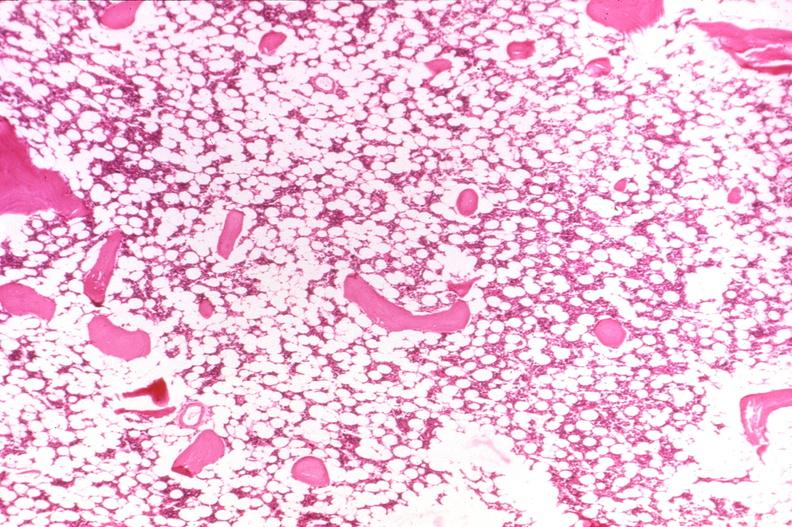does this image show bone, osteoporosis?
Answer the question using a single word or phrase. Yes 